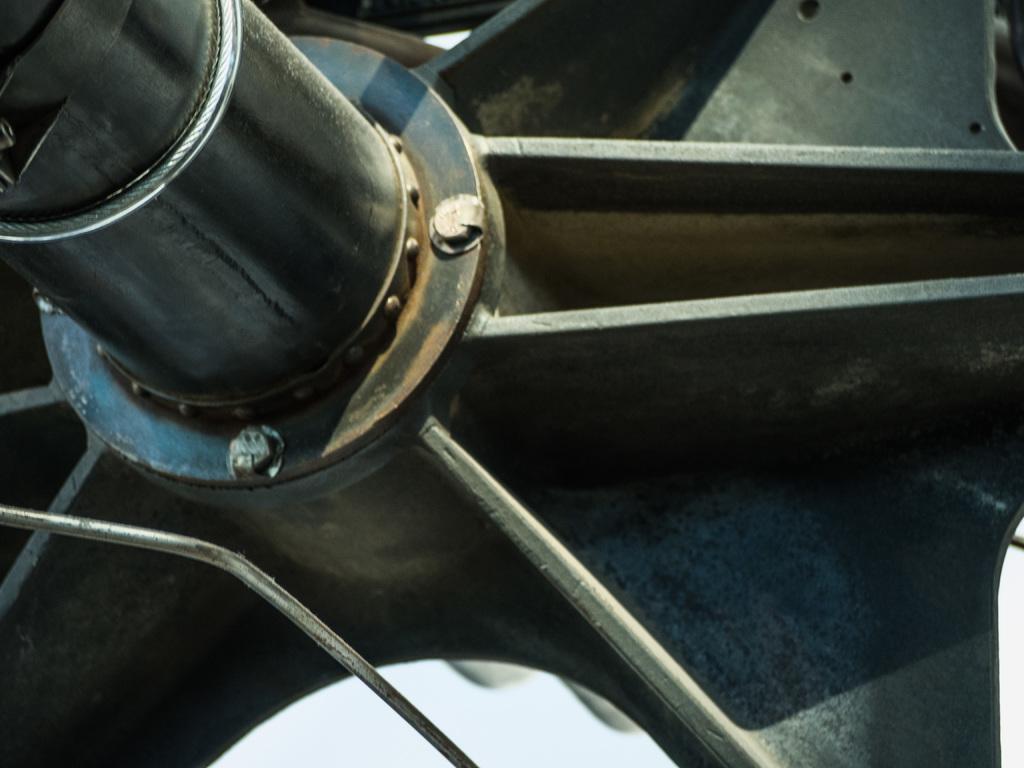Please provide a concise description of this image. In this image I can see the iron wheel. 